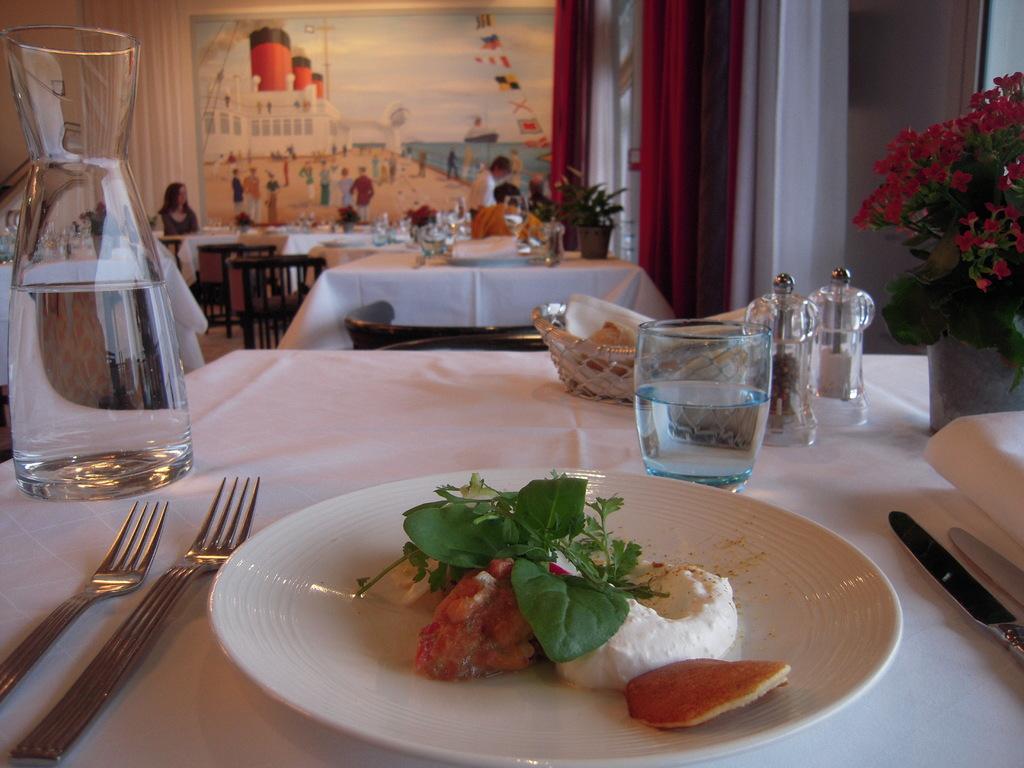In one or two sentences, can you explain what this image depicts? In this picture this a table with water jar, water glass and plate with food. 